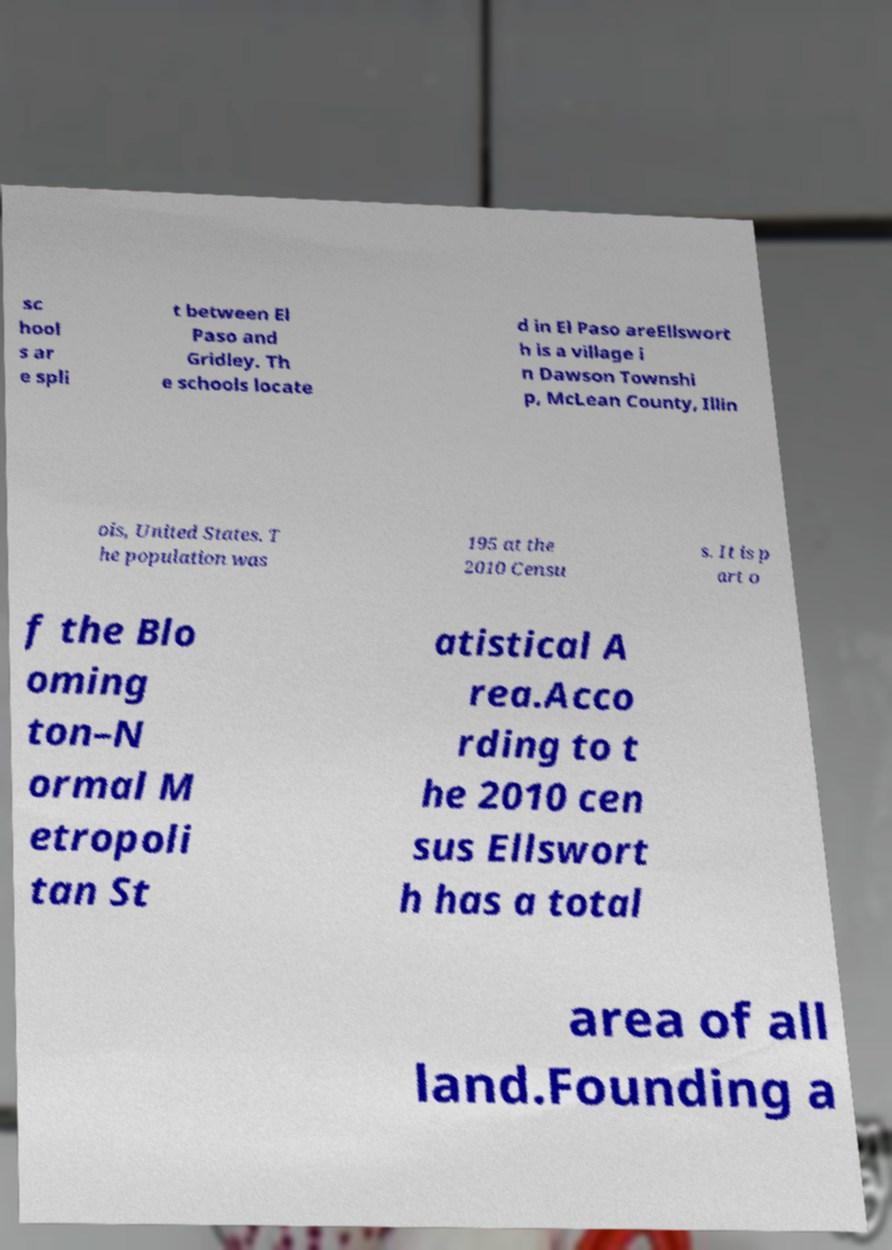For documentation purposes, I need the text within this image transcribed. Could you provide that? sc hool s ar e spli t between El Paso and Gridley. Th e schools locate d in El Paso areEllswort h is a village i n Dawson Townshi p, McLean County, Illin ois, United States. T he population was 195 at the 2010 Censu s. It is p art o f the Blo oming ton–N ormal M etropoli tan St atistical A rea.Acco rding to t he 2010 cen sus Ellswort h has a total area of all land.Founding a 